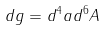Convert formula to latex. <formula><loc_0><loc_0><loc_500><loc_500>d g = d ^ { 4 } a d ^ { 6 } A</formula> 